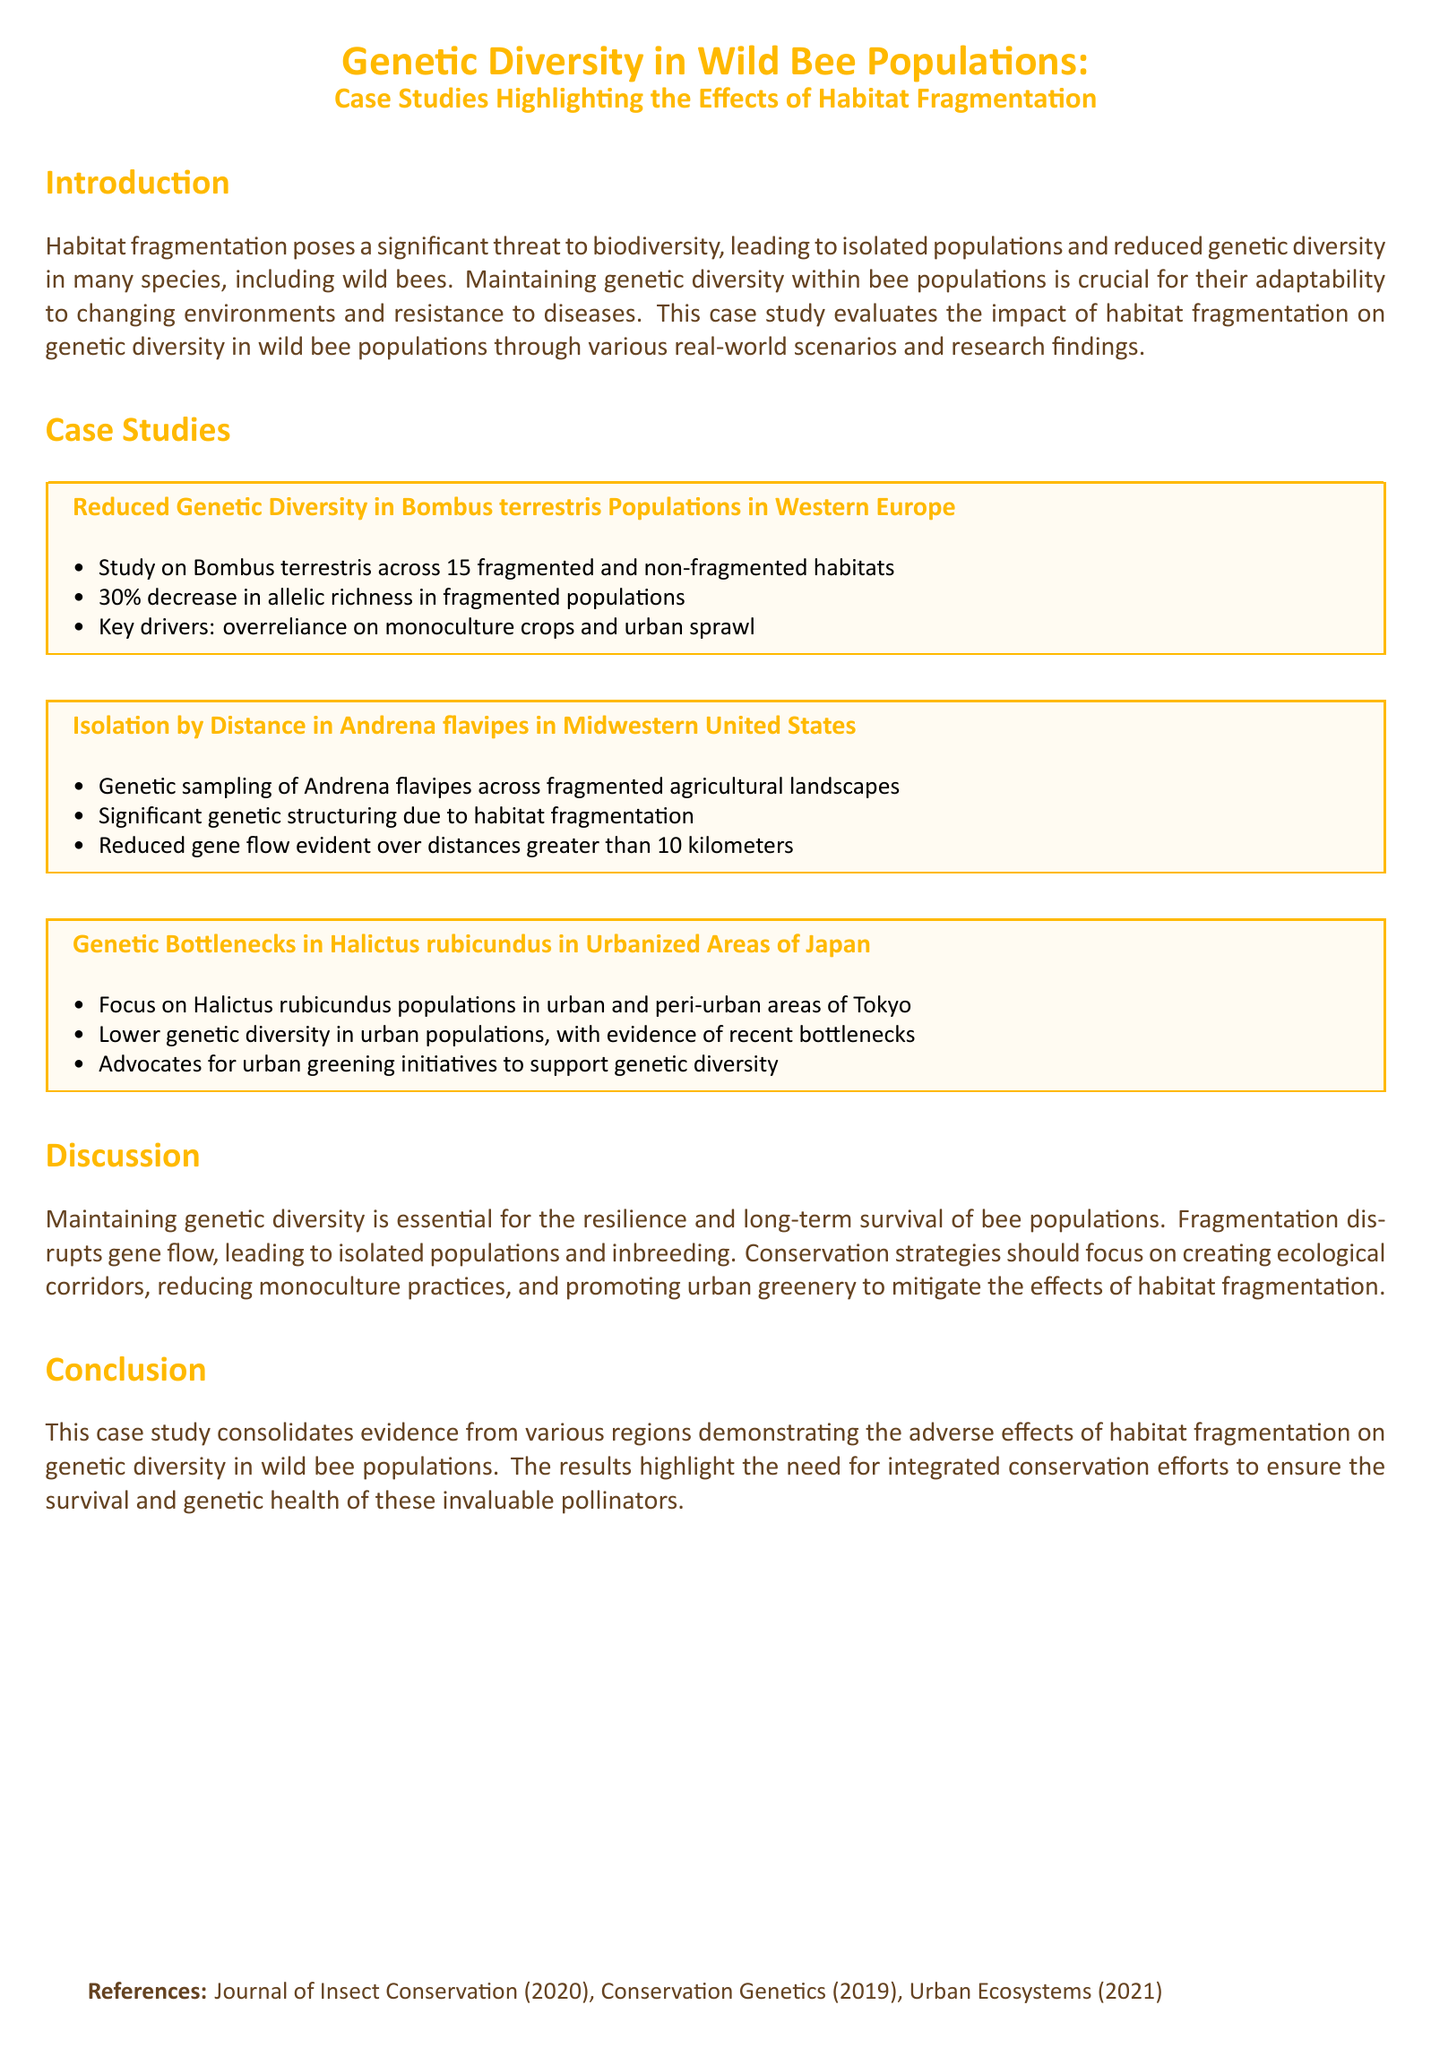what is the title of the case study? The title of the case study is "Genetic Diversity in Wild Bee Populations: Case Studies Highlighting the Effects of Habitat Fragmentation."
Answer: Genetic Diversity in Wild Bee Populations: Case Studies Highlighting the Effects of Habitat Fragmentation how many case studies are presented in the document? The document presents three case studies evaluating the effects of habitat fragmentation on wild bee populations.
Answer: three what species is studied in the first case study? The first case study focuses on Bombus terrestris populations in Western Europe.
Answer: Bombus terrestris what was the percentage decrease in allelic richness in fragmented populations for Bombus terrestris? The document states a 30% decrease in allelic richness in fragmented populations of Bombus terrestris.
Answer: 30% what is one proposed conservation strategy mentioned in the discussion? The discussion advocates creating ecological corridors as a conservation strategy to mitigate habitat fragmentation effects.
Answer: creating ecological corridors what does habitat fragmentation lead to in bee populations? The document explains that habitat fragmentation leads to isolated populations and inbreeding.
Answer: isolated populations and inbreeding what type of landscapes were studied for Andrena flavipes? The genetic sampling of Andrena flavipes was conducted across fragmented agricultural landscapes.
Answer: fragmented agricultural landscapes which urbanized area in Japan is mentioned in the case studies? The study mentions urban and peri-urban areas of Tokyo for Halictus rubicundus populations.
Answer: Tokyo what is the document's primary focus? The primary focus of the document is on the impact of habitat fragmentation on genetic diversity in wild bee populations.
Answer: impact of habitat fragmentation on genetic diversity in wild bee populations 